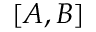<formula> <loc_0><loc_0><loc_500><loc_500>[ A , B ]</formula> 